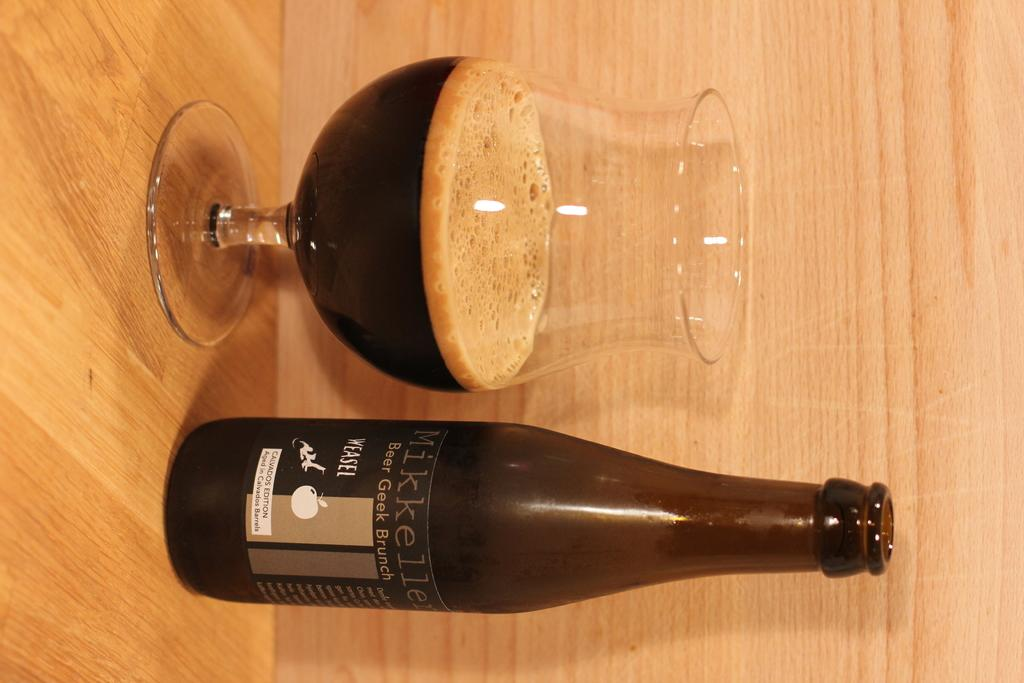Provide a one-sentence caption for the provided image. a glass and bottle of Beer Geek Brunch on a table. 